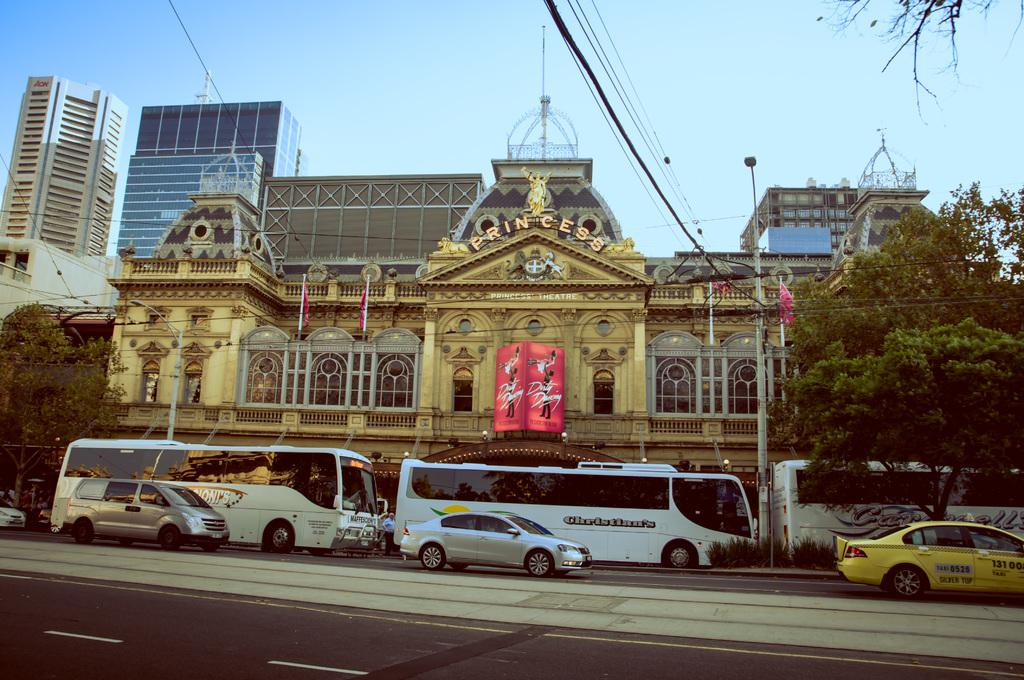<image>
Provide a brief description of the given image. A busy street in front of an ornate building advertising Dirty Dancing 